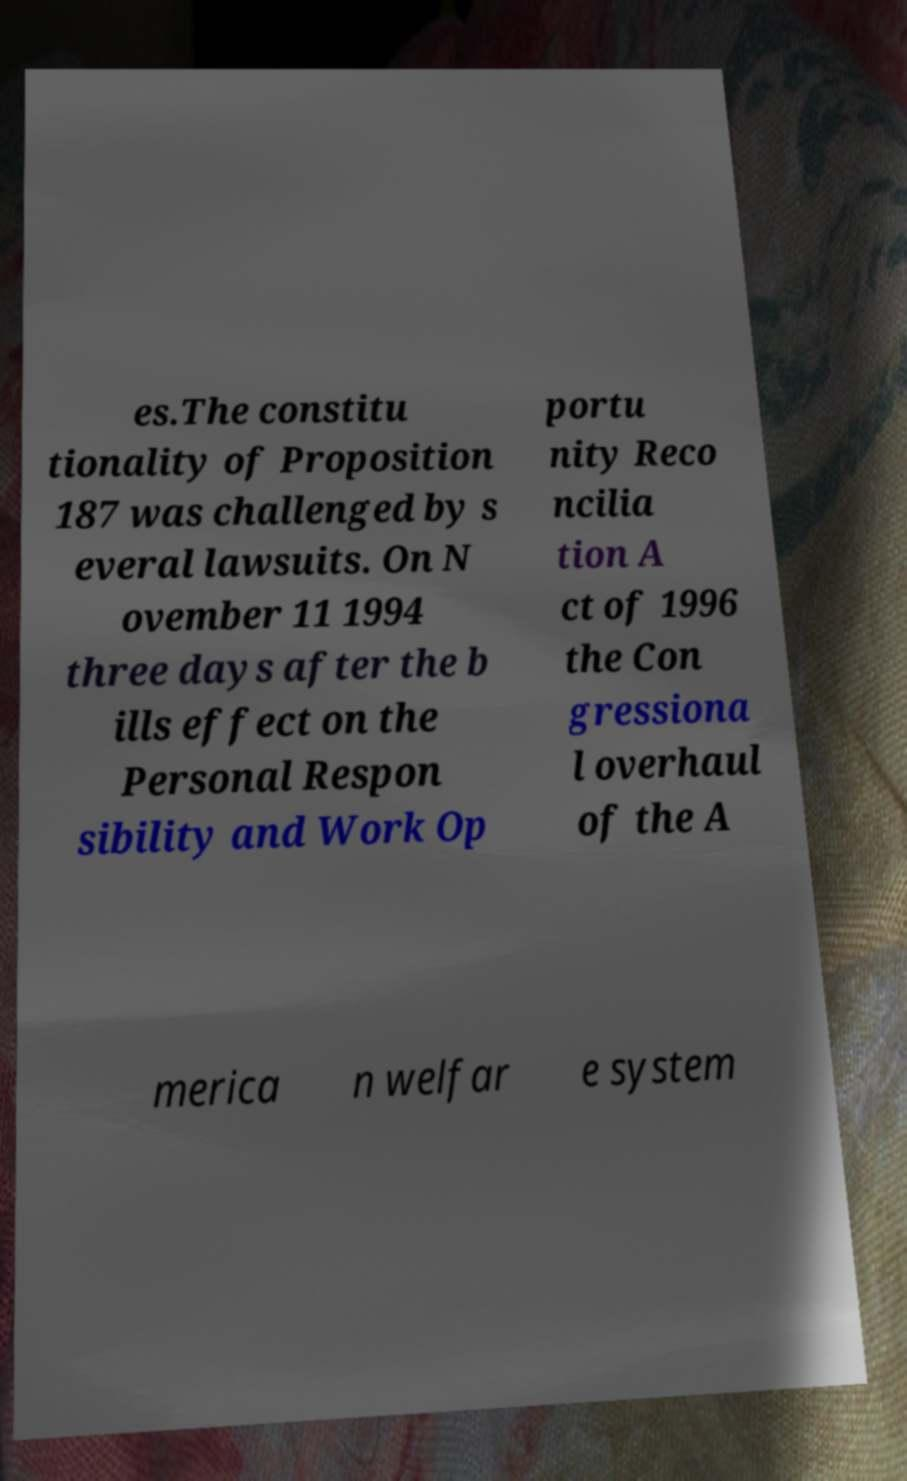There's text embedded in this image that I need extracted. Can you transcribe it verbatim? es.The constitu tionality of Proposition 187 was challenged by s everal lawsuits. On N ovember 11 1994 three days after the b ills effect on the Personal Respon sibility and Work Op portu nity Reco ncilia tion A ct of 1996 the Con gressiona l overhaul of the A merica n welfar e system 